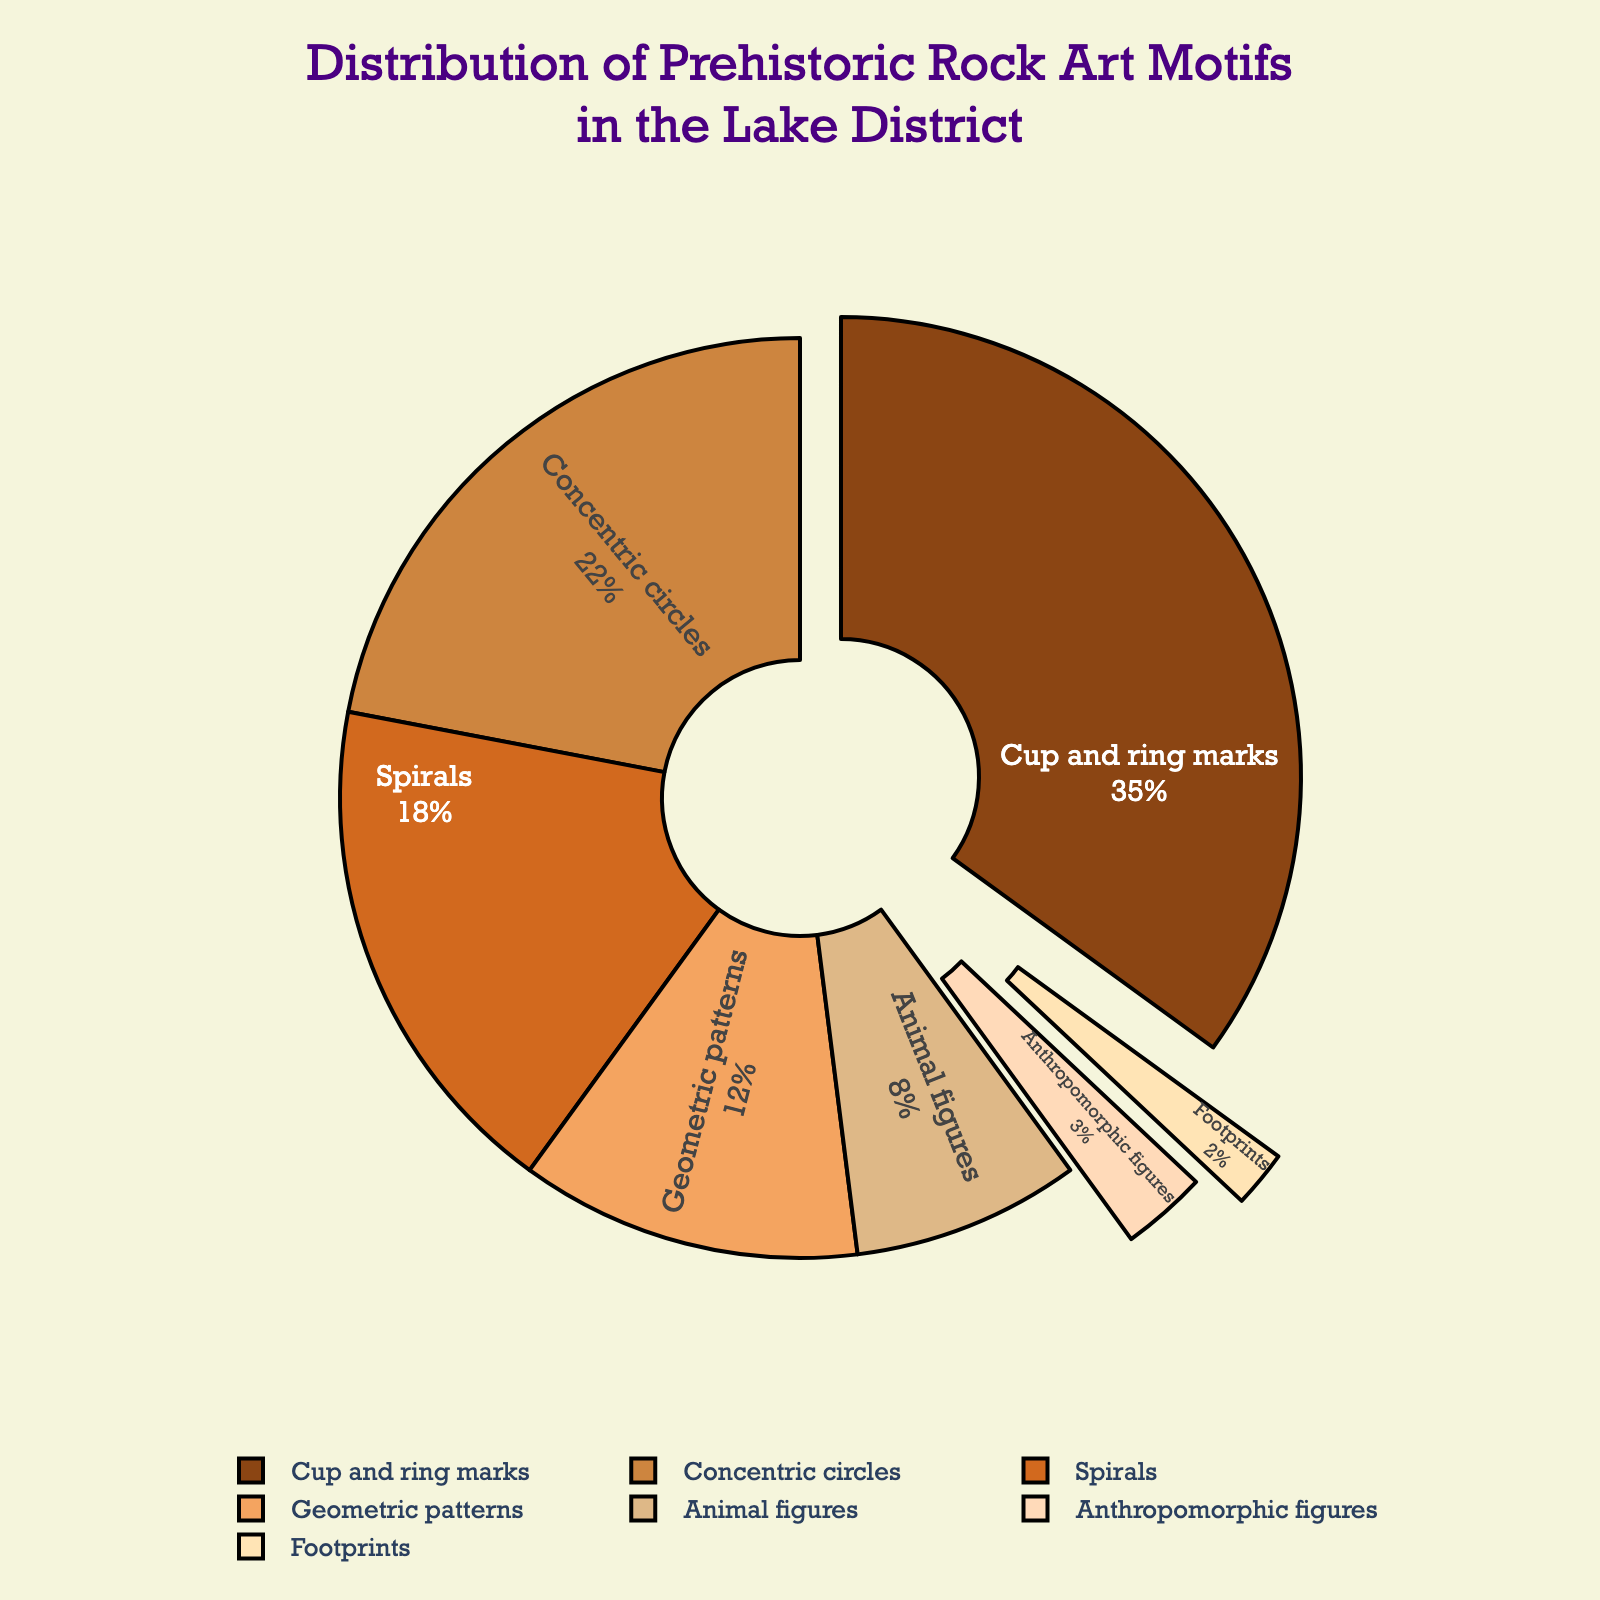Which motif has the largest percentage in the distribution? By examining the pie chart, we can see that the largest segment corresponds to the "Cup and ring marks" category.
Answer: Cup and ring marks Which motifs have less than 10% representation? From the pie chart, the motifs with less than 10% are "Animal figures," "Anthropomorphic figures," and "Footprints."
Answer: Animal figures, Anthropomorphic figures, Footprints How much more prevalent are geometric patterns compared to animal figures? The percentage for geometric patterns is 12%, and for animal figures, it is 8%. By subtracting 8 from 12, we find that geometric patterns are 4% more prevalent.
Answer: 4% What is the combined percentage of cup and ring marks and concentric circles? Cup and ring marks account for 35%, and concentric circles account for 22%. Adding these two gives 35 + 22 = 57%.
Answer: 57% Which motif is depicted in the smallest segment of the pie chart? By checking the smallest segment in the pie chart, we see it corresponds to "Footprints," which have the smallest percentage.
Answer: Footprints Among the spirals and anthropomorphic figures, which motif is more common and by how much? Spirals have 18% representation, while anthropomorphic figures have 3%. Subtracting 3 from 18 shows spirals are 15% more common than anthropomorphic figures.
Answer: 15% What is the difference in representation between the top two motifs? The top two motifs are cup and ring marks (35%) and concentric circles (22%). The difference is calculated by subtracting 22 from 35, which is 13%.
Answer: 13% If we combine the percentages of spirals and geometric patterns, do they exceed the percentage of cup and ring marks? By how much? Spirals have 18% and geometric patterns have 12%. Combined, they total 18 + 12 = 30%. Since cup and ring marks are 35%, they do not exceed it. The difference is 35 - 30 = 5%.
Answer: No, 5% What percentage of the motifs are representational figures (animal figures and anthropomorphic figures)? Adding the percentages for animal figures (8%) and anthropomorphic figures (3%) gives us a total of 11%.
Answer: 11% What is the difference in percentage between concentric circles and spirals? Concentric circles have 22% and spirals have 18%. The difference is found by subtracting 18 from 22, which equals 4%.
Answer: 4% 